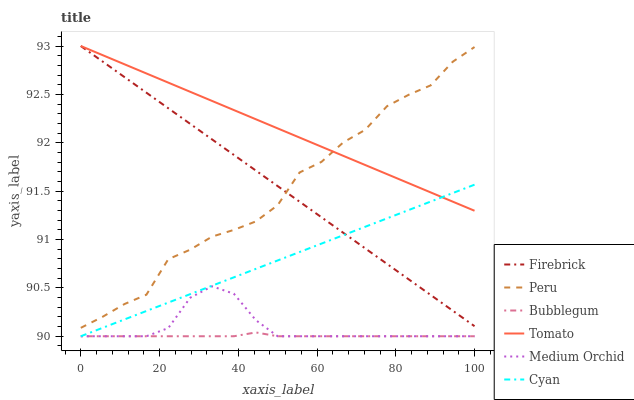Does Bubblegum have the minimum area under the curve?
Answer yes or no. Yes. Does Tomato have the maximum area under the curve?
Answer yes or no. Yes. Does Firebrick have the minimum area under the curve?
Answer yes or no. No. Does Firebrick have the maximum area under the curve?
Answer yes or no. No. Is Firebrick the smoothest?
Answer yes or no. Yes. Is Peru the roughest?
Answer yes or no. Yes. Is Medium Orchid the smoothest?
Answer yes or no. No. Is Medium Orchid the roughest?
Answer yes or no. No. Does Firebrick have the lowest value?
Answer yes or no. No. Does Firebrick have the highest value?
Answer yes or no. Yes. Does Medium Orchid have the highest value?
Answer yes or no. No. Is Medium Orchid less than Peru?
Answer yes or no. Yes. Is Peru greater than Cyan?
Answer yes or no. Yes. Does Firebrick intersect Peru?
Answer yes or no. Yes. Is Firebrick less than Peru?
Answer yes or no. No. Is Firebrick greater than Peru?
Answer yes or no. No. Does Medium Orchid intersect Peru?
Answer yes or no. No. 